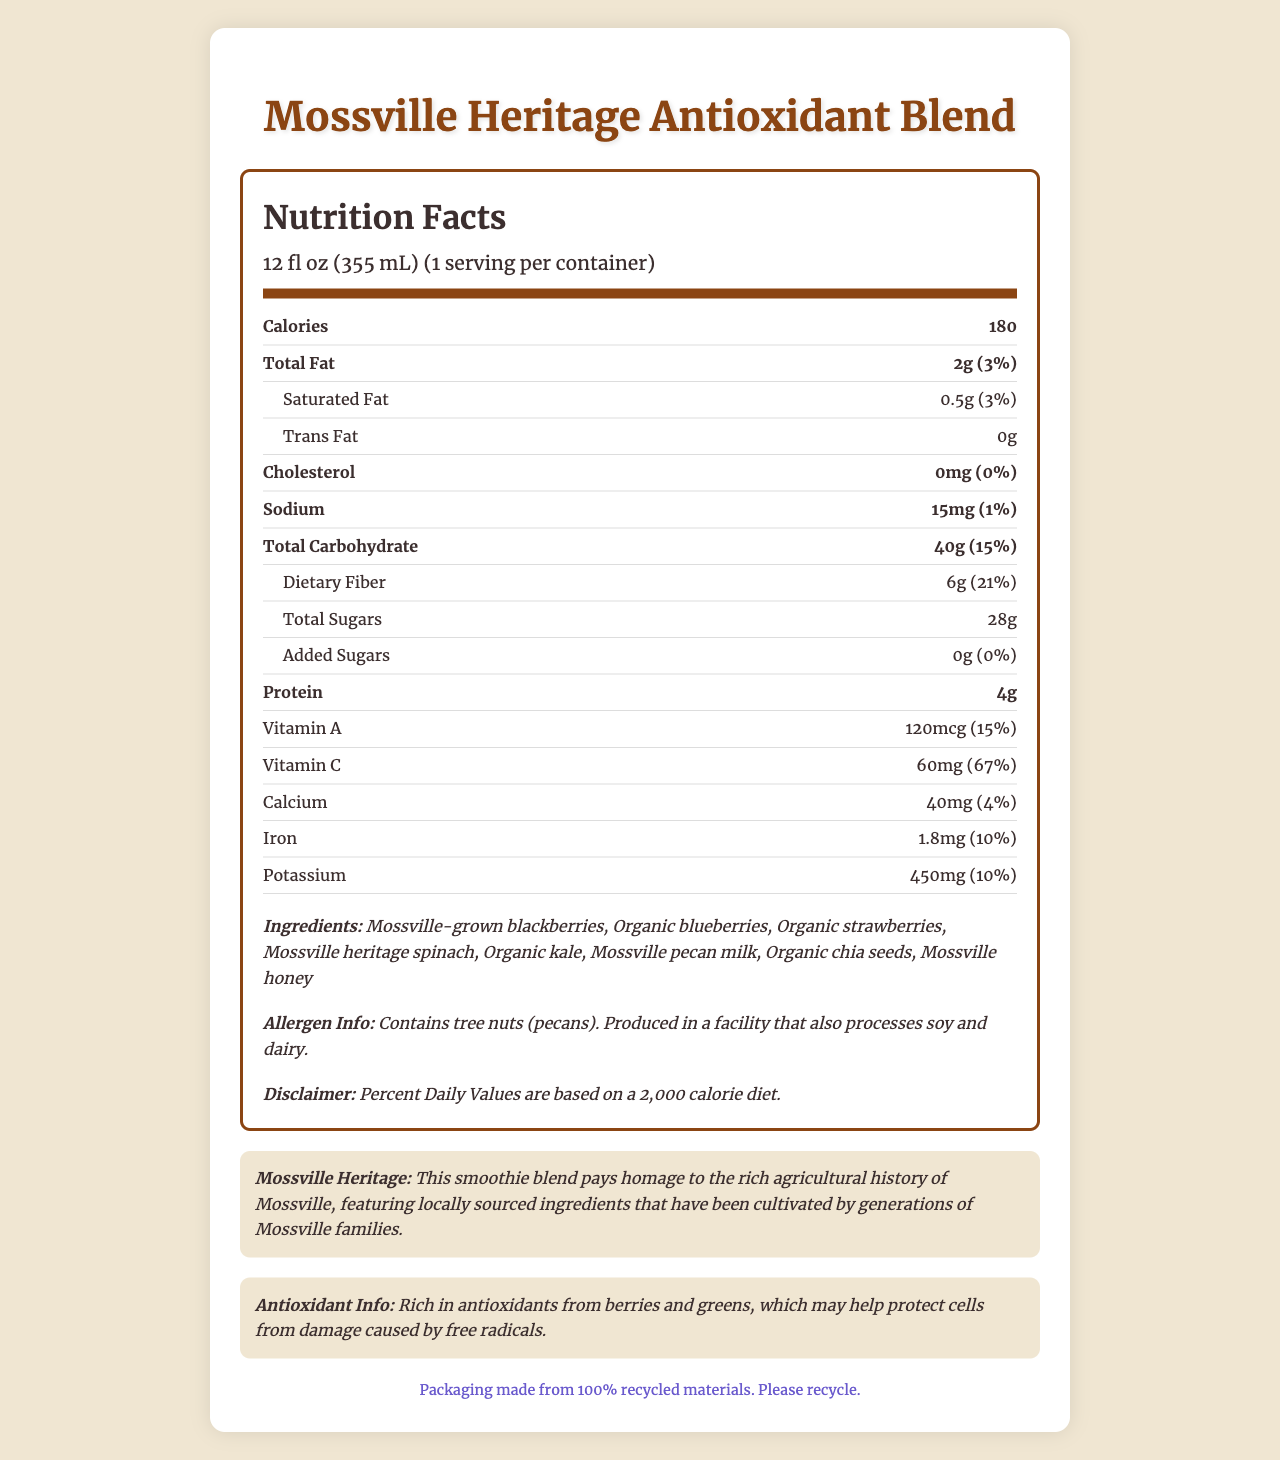what is the serving size of the Mossville Heritage Antioxidant Blend? The serving size is mentioned under the nutrition header as 12 fl oz (355 mL).
Answer: 12 fl oz (355 mL) how many calories are in one serving? The calorie count per serving is listed as 180 in the main nutrient row.
Answer: 180 how much dietary fiber is in the blend? The dietary fiber is listed as 6g in the nutrient row under total carbohydrate.
Answer: 6g what ingredient gives this product a nutty flavor? The list of ingredients includes Mossville pecan milk, which is likely to give the product a nutty flavor.
Answer: Mossville pecan milk what nutritional content has the highest daily value percentage? Vitamin C has the highest daily value percentage of 67% according to the nutrient rows.
Answer: Vitamin C (67%) how many grams of added sugars are in this blend? The amount of added sugars is 0g as indicated in the sub-nutrient row.
Answer: 0g what is the percentage daily value of Iron in this product? The daily value percentage for Iron is listed as 10% in the nutrient row.
Answer: 10% which of these vitamins is included in the Mossville Heritage Antioxidant Blend? A. Vitamin D B. Vitamin B12 C. Vitamin A D. Vitamin E The nutrition label lists Vitamin A with 120 mcg and 15% daily value.
Answer: C. Vitamin A what is the total carbohydrate content per serving? A. 20g B. 35g C. 40g D. 50g The total carbohydrate content per serving is 40g as stated in the nutrient row for total carbohydrate.
Answer: C. 40g does this product contain cholesterol? The label lists cholesterol as 0mg with 0% daily value, indicating the product contains no cholesterol.
Answer: No summarize the main focus of the document. The document primarily provides nutritional information, ingredients, and background about the Mossville Heritage Antioxidant Blend, highlighting its health benefits and sustainability efforts.
Answer: The document is a nutrition facts label for Mossville Heritage Antioxidant Blend, a smoothie featuring berries and greens. It lists the serving size, calories, detailed nutrient content, ingredients, allergen information, and a note on its Mossville heritage and sustainability. what is the source of antioxidants in this blend? The document mentions the blend is rich in antioxidants from berries and greens.
Answer: Berries and greens is the packaging of the product environmentally friendly? The document includes a sustainability note stating the packaging is made from 100% recycled materials.
Answer: Yes does the facility producing this blend also process any other allergens? The document notes that the facility also processes soy and dairy.
Answer: Yes what is the exact amount of sodium in the product? The amount of sodium is listed as 15mg in the nutrient row.
Answer: 15mg What is Mossville heritage spinach? The document lists Mossville heritage spinach as an ingredient but does not provide additional details about it specifically.
Answer: Not enough information 